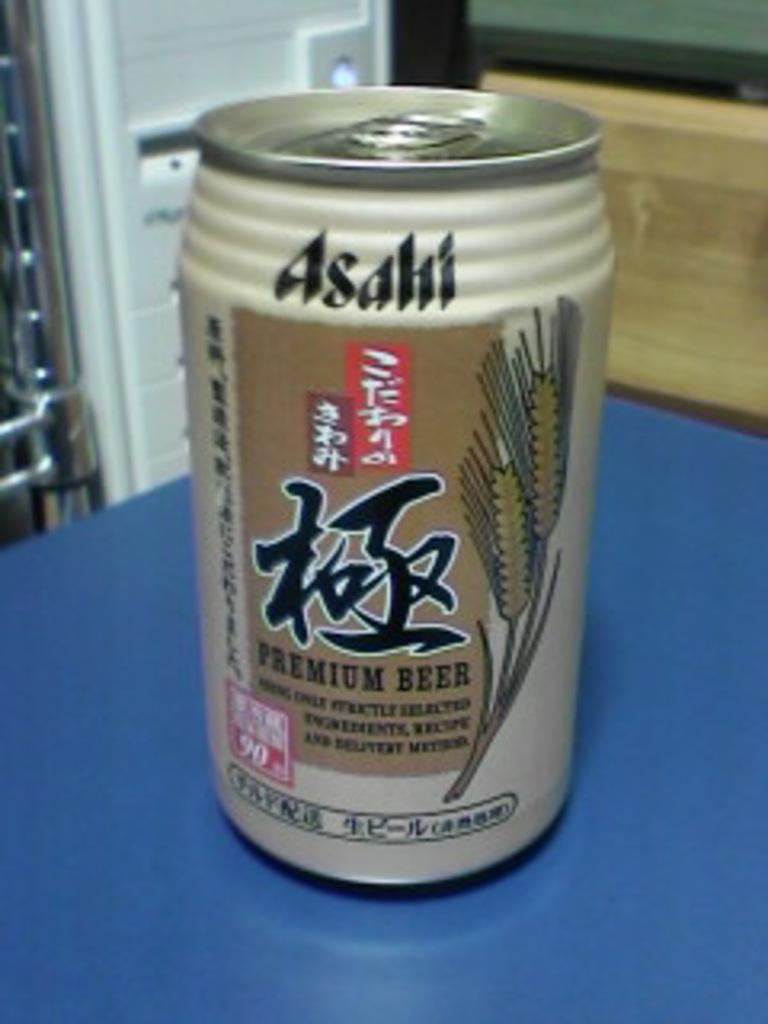Provide a one-sentence caption for the provided image. A can of Premium beer with Japanese characters on the can. 